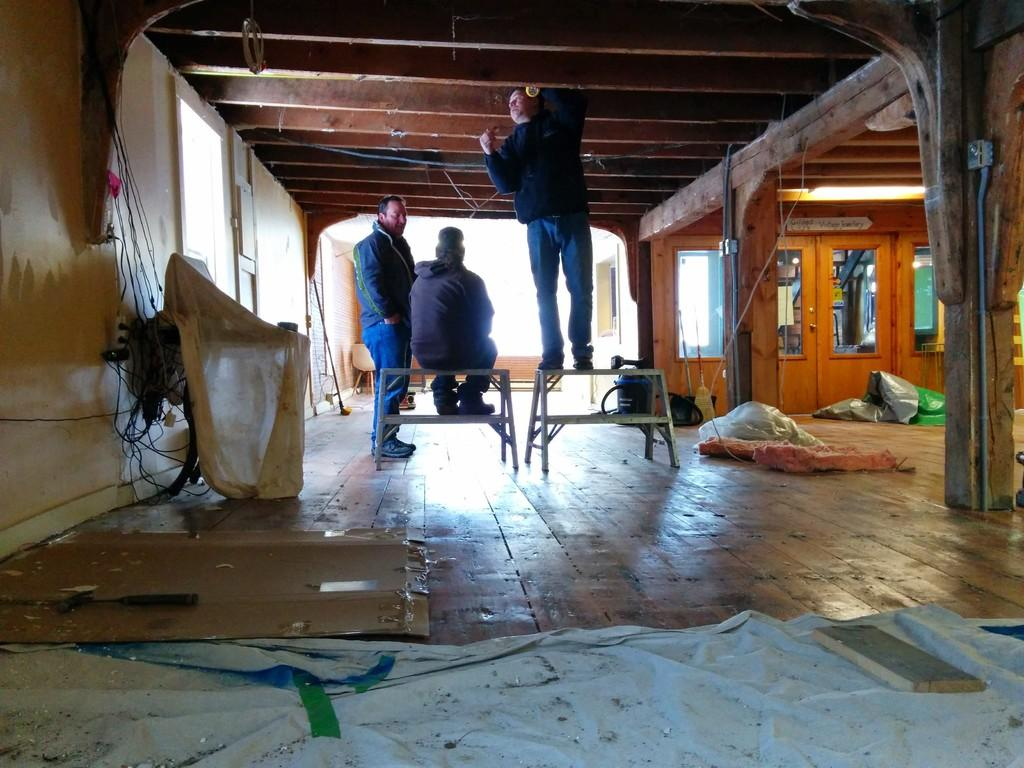How many people are in the image? There are three men in the middle of the image. What can be seen on the right side of the image? There are doors on the right side of the image. What is on the left side of the image? There is a wall on the left side of the image. What type of feet can be seen on the men in the image? There is no information about the men's feet in the image, so we cannot determine their type. 